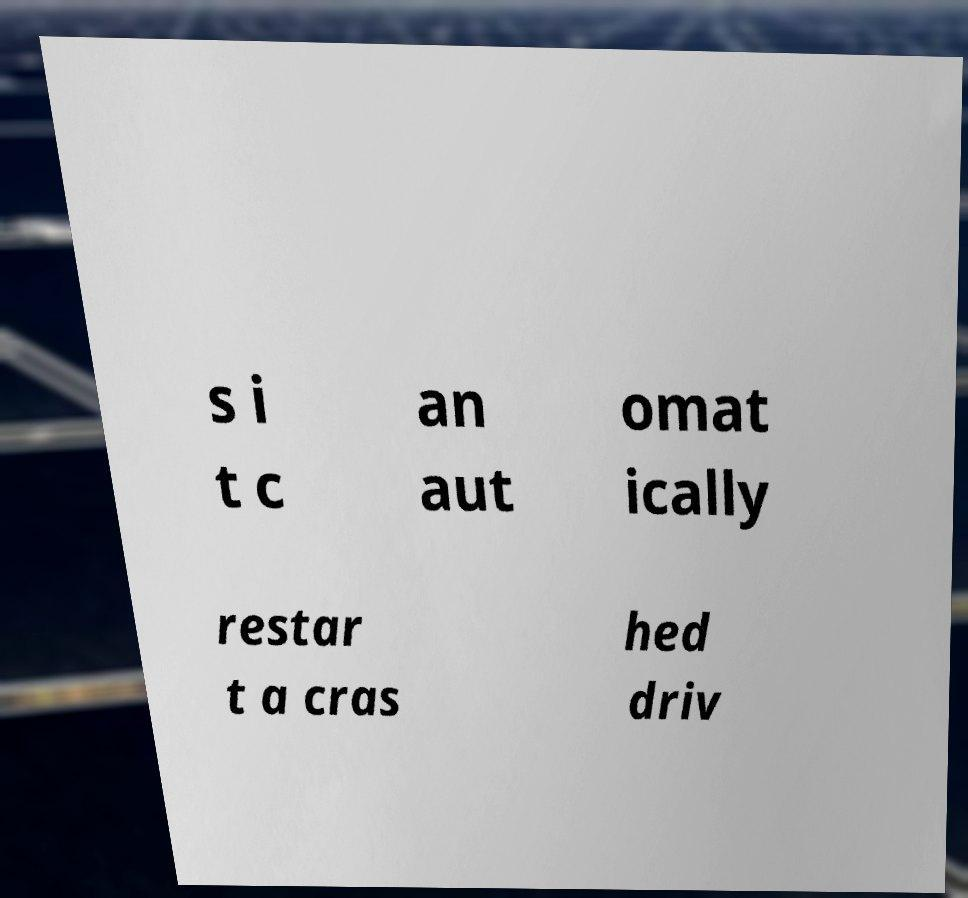I need the written content from this picture converted into text. Can you do that? s i t c an aut omat ically restar t a cras hed driv 